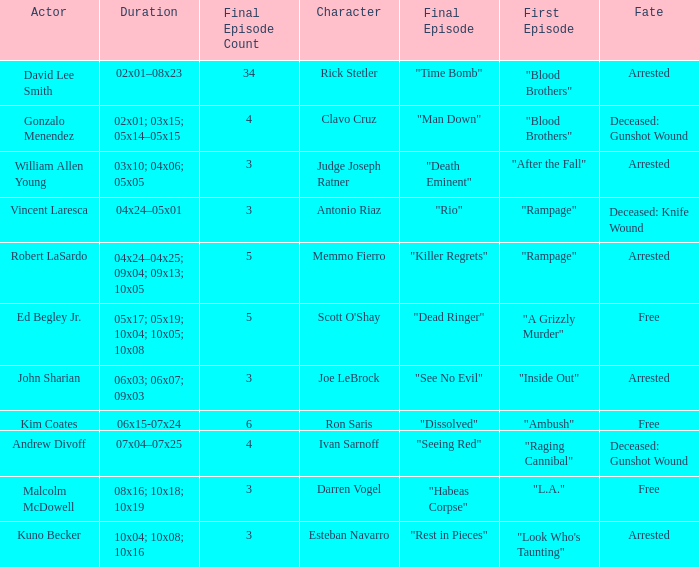Write the full table. {'header': ['Actor', 'Duration', 'Final Episode Count', 'Character', 'Final Episode', 'First Episode', 'Fate'], 'rows': [['David Lee Smith', '02x01–08x23', '34', 'Rick Stetler', '"Time Bomb"', '"Blood Brothers"', 'Arrested'], ['Gonzalo Menendez', '02x01; 03x15; 05x14–05x15', '4', 'Clavo Cruz', '"Man Down"', '"Blood Brothers"', 'Deceased: Gunshot Wound'], ['William Allen Young', '03x10; 04x06; 05x05', '3', 'Judge Joseph Ratner', '"Death Eminent"', '"After the Fall"', 'Arrested'], ['Vincent Laresca', '04x24–05x01', '3', 'Antonio Riaz', '"Rio"', '"Rampage"', 'Deceased: Knife Wound'], ['Robert LaSardo', '04x24–04x25; 09x04; 09x13; 10x05', '5', 'Memmo Fierro', '"Killer Regrets"', '"Rampage"', 'Arrested'], ['Ed Begley Jr.', '05x17; 05x19; 10x04; 10x05; 10x08', '5', "Scott O'Shay", '"Dead Ringer"', '"A Grizzly Murder"', 'Free'], ['John Sharian', '06x03; 06x07; 09x03', '3', 'Joe LeBrock', '"See No Evil"', '"Inside Out"', 'Arrested'], ['Kim Coates', '06x15-07x24', '6', 'Ron Saris', '"Dissolved"', '"Ambush"', 'Free'], ['Andrew Divoff', '07x04–07x25', '4', 'Ivan Sarnoff', '"Seeing Red"', '"Raging Cannibal"', 'Deceased: Gunshot Wound'], ['Malcolm McDowell', '08x16; 10x18; 10x19', '3', 'Darren Vogel', '"Habeas Corpse"', '"L.A."', 'Free'], ['Kuno Becker', '10x04; 10x08; 10x16', '3', 'Esteban Navarro', '"Rest in Pieces"', '"Look Who\'s Taunting"', 'Arrested']]} What's the character with fate being deceased: knife wound Antonio Riaz. 